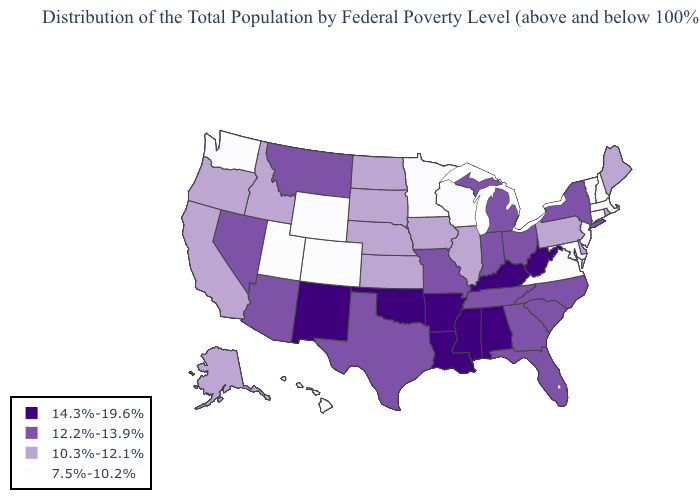What is the value of Arkansas?
Keep it brief. 14.3%-19.6%. Name the states that have a value in the range 12.2%-13.9%?
Give a very brief answer. Arizona, Florida, Georgia, Indiana, Michigan, Missouri, Montana, Nevada, New York, North Carolina, Ohio, South Carolina, Tennessee, Texas. Among the states that border Massachusetts , does New Hampshire have the highest value?
Concise answer only. No. Does Nevada have a higher value than Arizona?
Give a very brief answer. No. Which states have the highest value in the USA?
Write a very short answer. Alabama, Arkansas, Kentucky, Louisiana, Mississippi, New Mexico, Oklahoma, West Virginia. Does California have the lowest value in the USA?
Answer briefly. No. How many symbols are there in the legend?
Write a very short answer. 4. Does the map have missing data?
Give a very brief answer. No. Which states have the highest value in the USA?
Quick response, please. Alabama, Arkansas, Kentucky, Louisiana, Mississippi, New Mexico, Oklahoma, West Virginia. Name the states that have a value in the range 7.5%-10.2%?
Keep it brief. Colorado, Connecticut, Hawaii, Maryland, Massachusetts, Minnesota, New Hampshire, New Jersey, Utah, Vermont, Virginia, Washington, Wisconsin, Wyoming. What is the value of Wyoming?
Write a very short answer. 7.5%-10.2%. What is the highest value in the South ?
Short answer required. 14.3%-19.6%. Does Colorado have the lowest value in the USA?
Give a very brief answer. Yes. Name the states that have a value in the range 7.5%-10.2%?
Quick response, please. Colorado, Connecticut, Hawaii, Maryland, Massachusetts, Minnesota, New Hampshire, New Jersey, Utah, Vermont, Virginia, Washington, Wisconsin, Wyoming. Among the states that border California , does Nevada have the lowest value?
Concise answer only. No. 